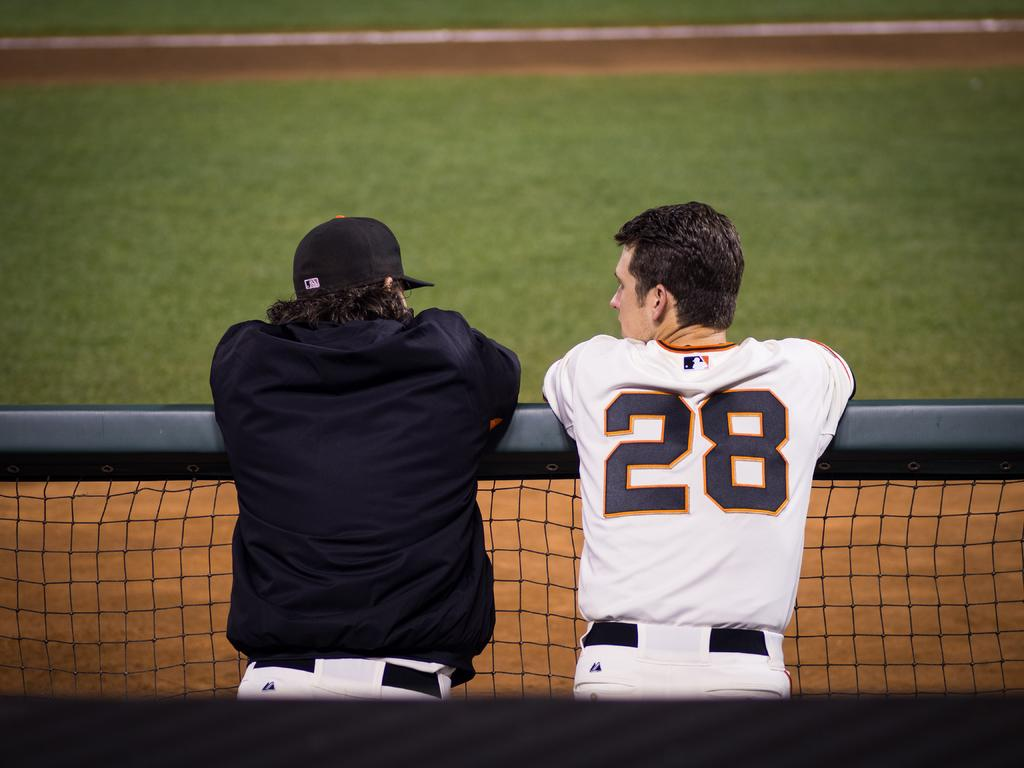Provide a one-sentence caption for the provided image. A man wearing number 28 on his jersey talking to another man by a fence. 